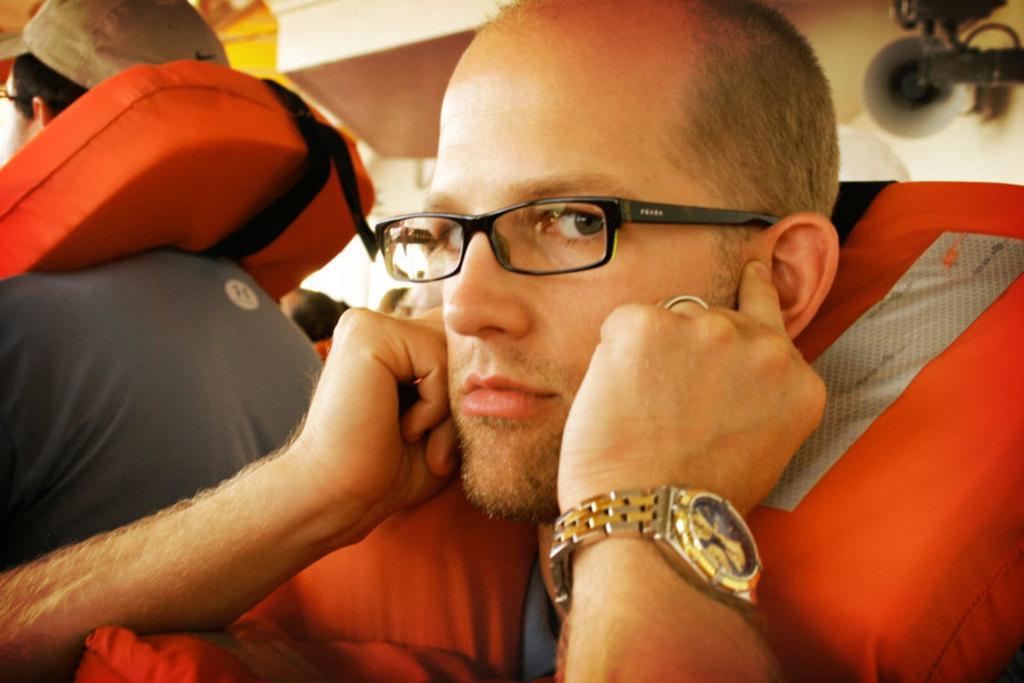Can you describe this image briefly? In this image I can see two persons and I can see both of them are wearing life jackets. I can also see one of them is wearing a specs, a watch and I can see another one is wearing a cap. On the top right side of this image I can see a speaker on the wall. 